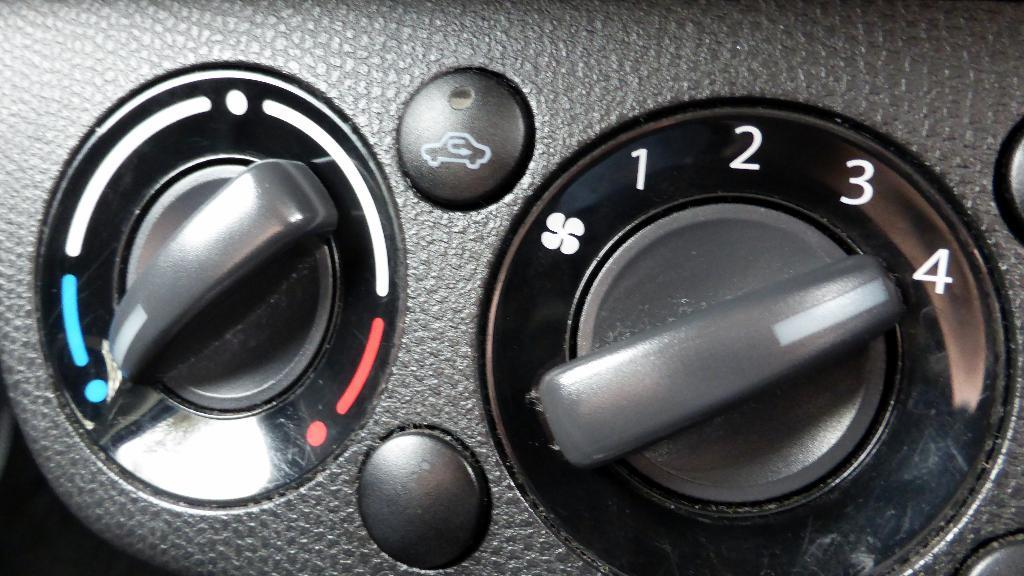What type of device might the controlling knobs and buttons be associated with in the image? The controlling knobs and buttons in the image could be associated with a device such as a stereo system or a television. What is the color of the buttons in the image? The buttons in the image are black. How many brothers are playing musical instruments in the image? There are no brothers or musical instruments present in the image. What letters are written on the buttons in the image? There is no information about letters written on the buttons in the image; only the color is mentioned. 